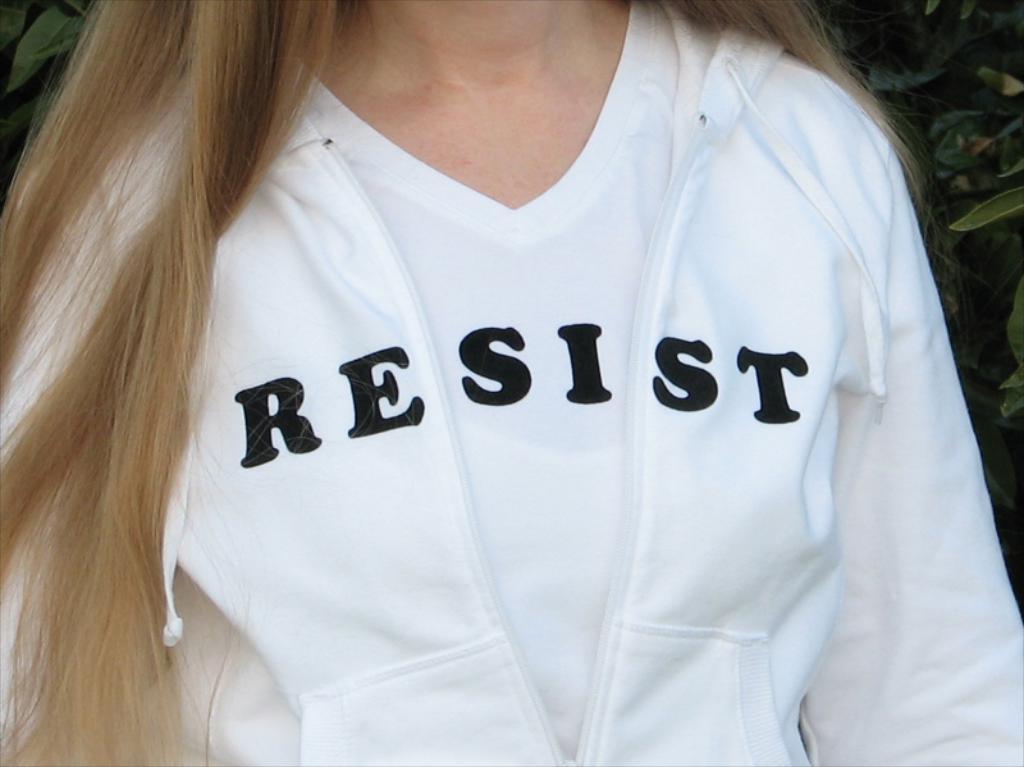What does the woman's shirt read?
Make the answer very short. Resist. What does the shirt say?
Provide a succinct answer. Resist. 